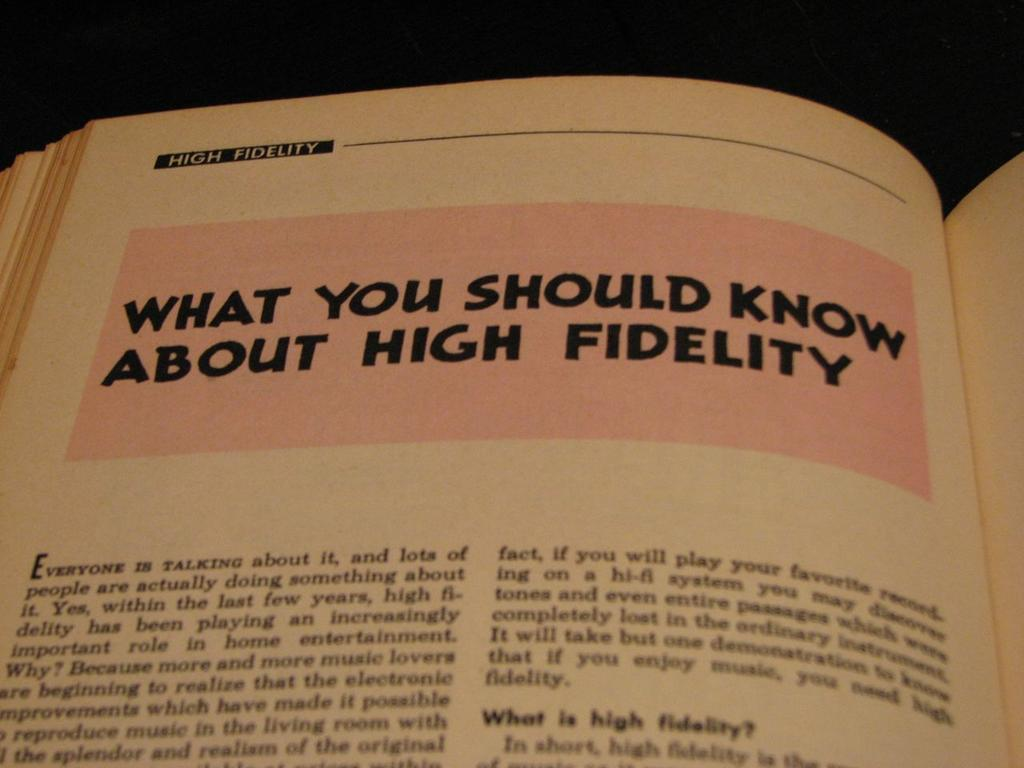<image>
Relay a brief, clear account of the picture shown. The chapter is titled What you Should Know about High Fidelity. 